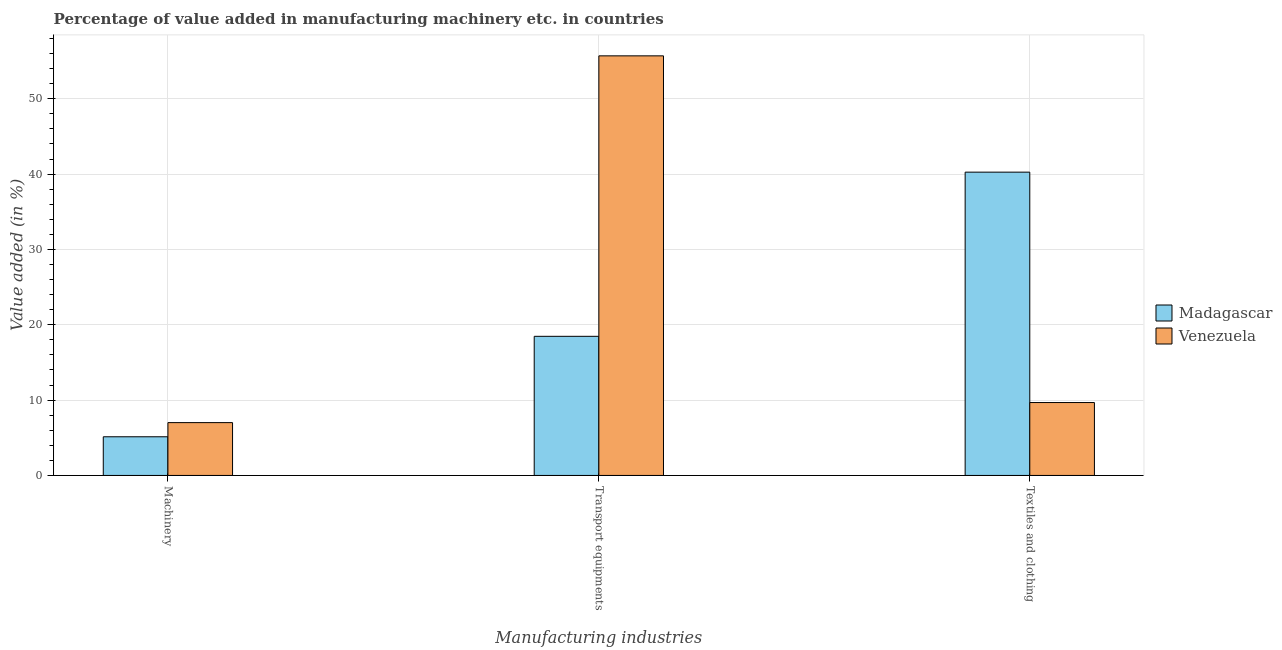How many different coloured bars are there?
Offer a terse response. 2. How many groups of bars are there?
Ensure brevity in your answer.  3. Are the number of bars per tick equal to the number of legend labels?
Provide a short and direct response. Yes. How many bars are there on the 1st tick from the left?
Make the answer very short. 2. What is the label of the 2nd group of bars from the left?
Offer a terse response. Transport equipments. What is the value added in manufacturing transport equipments in Venezuela?
Your response must be concise. 55.7. Across all countries, what is the maximum value added in manufacturing textile and clothing?
Give a very brief answer. 40.26. Across all countries, what is the minimum value added in manufacturing transport equipments?
Your response must be concise. 18.47. In which country was the value added in manufacturing machinery maximum?
Your answer should be compact. Venezuela. In which country was the value added in manufacturing textile and clothing minimum?
Your answer should be compact. Venezuela. What is the total value added in manufacturing textile and clothing in the graph?
Offer a very short reply. 49.94. What is the difference between the value added in manufacturing textile and clothing in Madagascar and that in Venezuela?
Keep it short and to the point. 30.58. What is the difference between the value added in manufacturing textile and clothing in Venezuela and the value added in manufacturing transport equipments in Madagascar?
Offer a terse response. -8.79. What is the average value added in manufacturing textile and clothing per country?
Ensure brevity in your answer.  24.97. What is the difference between the value added in manufacturing machinery and value added in manufacturing textile and clothing in Madagascar?
Offer a terse response. -35.13. What is the ratio of the value added in manufacturing machinery in Venezuela to that in Madagascar?
Make the answer very short. 1.37. Is the value added in manufacturing transport equipments in Madagascar less than that in Venezuela?
Make the answer very short. Yes. Is the difference between the value added in manufacturing transport equipments in Venezuela and Madagascar greater than the difference between the value added in manufacturing machinery in Venezuela and Madagascar?
Provide a short and direct response. Yes. What is the difference between the highest and the second highest value added in manufacturing transport equipments?
Offer a terse response. 37.23. What is the difference between the highest and the lowest value added in manufacturing machinery?
Give a very brief answer. 1.88. In how many countries, is the value added in manufacturing machinery greater than the average value added in manufacturing machinery taken over all countries?
Make the answer very short. 1. What does the 1st bar from the left in Transport equipments represents?
Provide a succinct answer. Madagascar. What does the 1st bar from the right in Transport equipments represents?
Your answer should be compact. Venezuela. Is it the case that in every country, the sum of the value added in manufacturing machinery and value added in manufacturing transport equipments is greater than the value added in manufacturing textile and clothing?
Your response must be concise. No. What is the difference between two consecutive major ticks on the Y-axis?
Provide a short and direct response. 10. Are the values on the major ticks of Y-axis written in scientific E-notation?
Offer a terse response. No. Does the graph contain grids?
Give a very brief answer. Yes. Where does the legend appear in the graph?
Your answer should be compact. Center right. What is the title of the graph?
Your answer should be compact. Percentage of value added in manufacturing machinery etc. in countries. Does "Uganda" appear as one of the legend labels in the graph?
Your response must be concise. No. What is the label or title of the X-axis?
Keep it short and to the point. Manufacturing industries. What is the label or title of the Y-axis?
Provide a short and direct response. Value added (in %). What is the Value added (in %) in Madagascar in Machinery?
Ensure brevity in your answer.  5.13. What is the Value added (in %) of Venezuela in Machinery?
Make the answer very short. 7.01. What is the Value added (in %) of Madagascar in Transport equipments?
Provide a short and direct response. 18.47. What is the Value added (in %) of Venezuela in Transport equipments?
Ensure brevity in your answer.  55.7. What is the Value added (in %) in Madagascar in Textiles and clothing?
Offer a terse response. 40.26. What is the Value added (in %) of Venezuela in Textiles and clothing?
Ensure brevity in your answer.  9.68. Across all Manufacturing industries, what is the maximum Value added (in %) of Madagascar?
Offer a terse response. 40.26. Across all Manufacturing industries, what is the maximum Value added (in %) in Venezuela?
Ensure brevity in your answer.  55.7. Across all Manufacturing industries, what is the minimum Value added (in %) of Madagascar?
Make the answer very short. 5.13. Across all Manufacturing industries, what is the minimum Value added (in %) of Venezuela?
Ensure brevity in your answer.  7.01. What is the total Value added (in %) in Madagascar in the graph?
Keep it short and to the point. 63.86. What is the total Value added (in %) of Venezuela in the graph?
Provide a short and direct response. 72.39. What is the difference between the Value added (in %) of Madagascar in Machinery and that in Transport equipments?
Provide a succinct answer. -13.33. What is the difference between the Value added (in %) of Venezuela in Machinery and that in Transport equipments?
Keep it short and to the point. -48.69. What is the difference between the Value added (in %) of Madagascar in Machinery and that in Textiles and clothing?
Your answer should be compact. -35.13. What is the difference between the Value added (in %) of Venezuela in Machinery and that in Textiles and clothing?
Your response must be concise. -2.66. What is the difference between the Value added (in %) in Madagascar in Transport equipments and that in Textiles and clothing?
Provide a succinct answer. -21.79. What is the difference between the Value added (in %) of Venezuela in Transport equipments and that in Textiles and clothing?
Keep it short and to the point. 46.02. What is the difference between the Value added (in %) of Madagascar in Machinery and the Value added (in %) of Venezuela in Transport equipments?
Provide a short and direct response. -50.57. What is the difference between the Value added (in %) in Madagascar in Machinery and the Value added (in %) in Venezuela in Textiles and clothing?
Offer a terse response. -4.54. What is the difference between the Value added (in %) in Madagascar in Transport equipments and the Value added (in %) in Venezuela in Textiles and clothing?
Provide a short and direct response. 8.79. What is the average Value added (in %) in Madagascar per Manufacturing industries?
Offer a very short reply. 21.29. What is the average Value added (in %) of Venezuela per Manufacturing industries?
Provide a succinct answer. 24.13. What is the difference between the Value added (in %) in Madagascar and Value added (in %) in Venezuela in Machinery?
Offer a very short reply. -1.88. What is the difference between the Value added (in %) in Madagascar and Value added (in %) in Venezuela in Transport equipments?
Keep it short and to the point. -37.23. What is the difference between the Value added (in %) in Madagascar and Value added (in %) in Venezuela in Textiles and clothing?
Offer a very short reply. 30.58. What is the ratio of the Value added (in %) in Madagascar in Machinery to that in Transport equipments?
Ensure brevity in your answer.  0.28. What is the ratio of the Value added (in %) in Venezuela in Machinery to that in Transport equipments?
Keep it short and to the point. 0.13. What is the ratio of the Value added (in %) in Madagascar in Machinery to that in Textiles and clothing?
Your answer should be very brief. 0.13. What is the ratio of the Value added (in %) in Venezuela in Machinery to that in Textiles and clothing?
Your answer should be very brief. 0.72. What is the ratio of the Value added (in %) in Madagascar in Transport equipments to that in Textiles and clothing?
Provide a short and direct response. 0.46. What is the ratio of the Value added (in %) in Venezuela in Transport equipments to that in Textiles and clothing?
Your answer should be very brief. 5.76. What is the difference between the highest and the second highest Value added (in %) in Madagascar?
Provide a short and direct response. 21.79. What is the difference between the highest and the second highest Value added (in %) in Venezuela?
Make the answer very short. 46.02. What is the difference between the highest and the lowest Value added (in %) in Madagascar?
Make the answer very short. 35.13. What is the difference between the highest and the lowest Value added (in %) of Venezuela?
Offer a terse response. 48.69. 